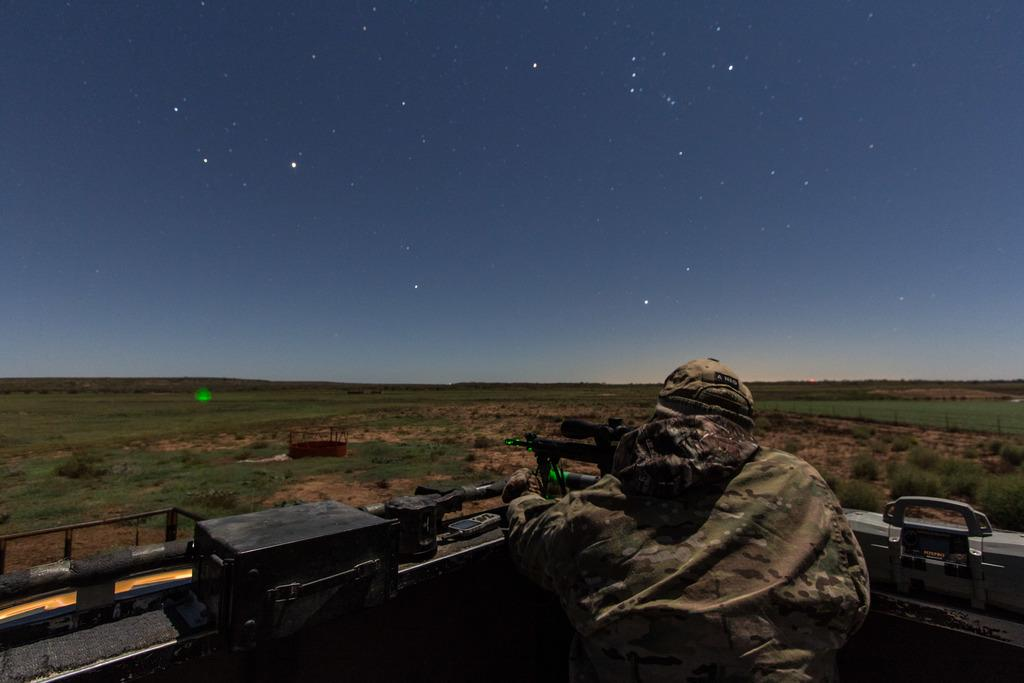Who or what is the main subject in the image? There is a person in the image. What else can be seen in the image besides the person? There are other objects in the image. What type of natural environment is visible in the background of the image? There is grass and a rocky surface in the background of the image. What is visible at the top of the image? The sky is visible at the top of the image. How many ducks are sitting on the lunchroom table in the image? There are no ducks or lunchroom tables present in the image. What type of bird is perched on the person's shoulder in the image? There is no bird visible on the person's shoulder in the image. 